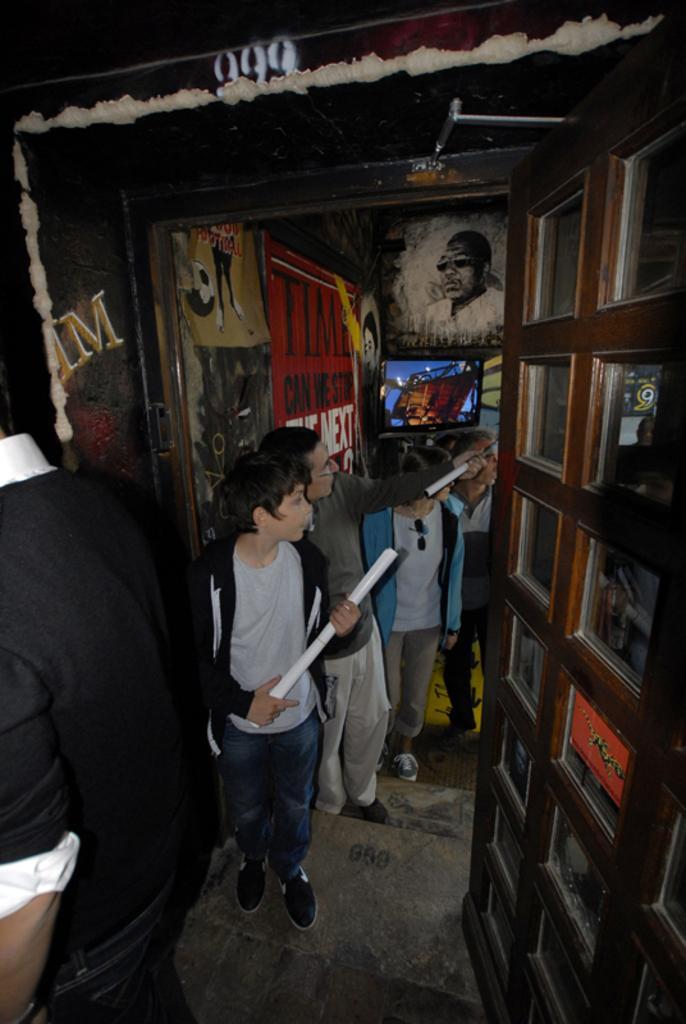How would you summarize this image in a sentence or two? In this picture we can see persons and in the background we can see posters. 